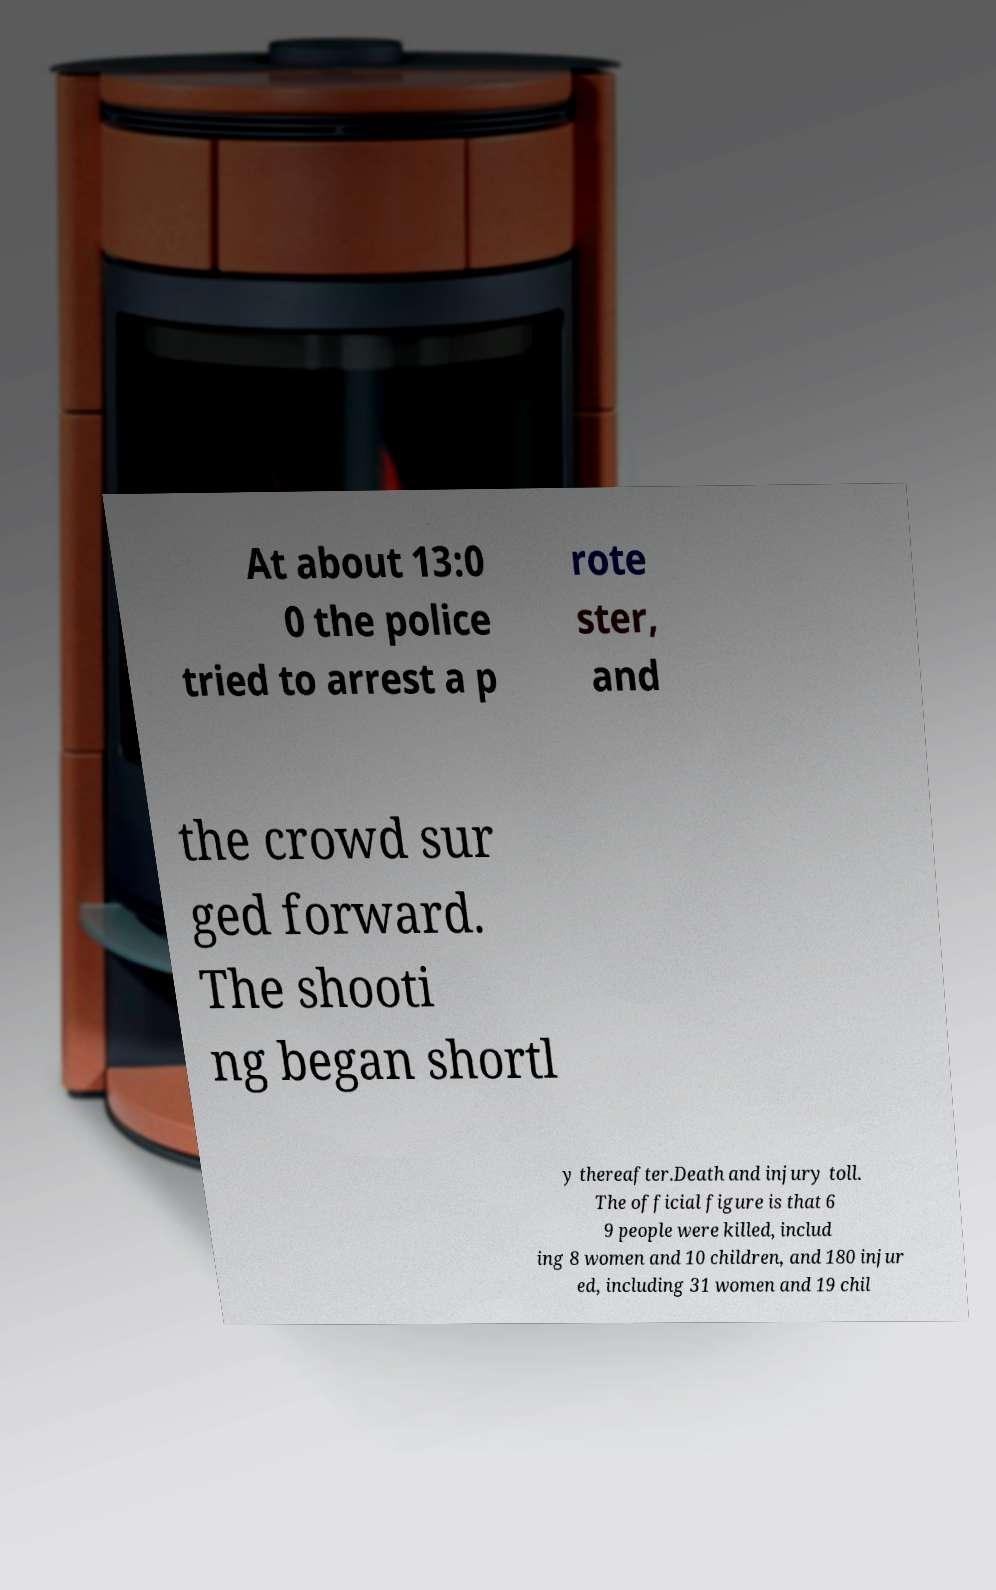Could you extract and type out the text from this image? At about 13:0 0 the police tried to arrest a p rote ster, and the crowd sur ged forward. The shooti ng began shortl y thereafter.Death and injury toll. The official figure is that 6 9 people were killed, includ ing 8 women and 10 children, and 180 injur ed, including 31 women and 19 chil 